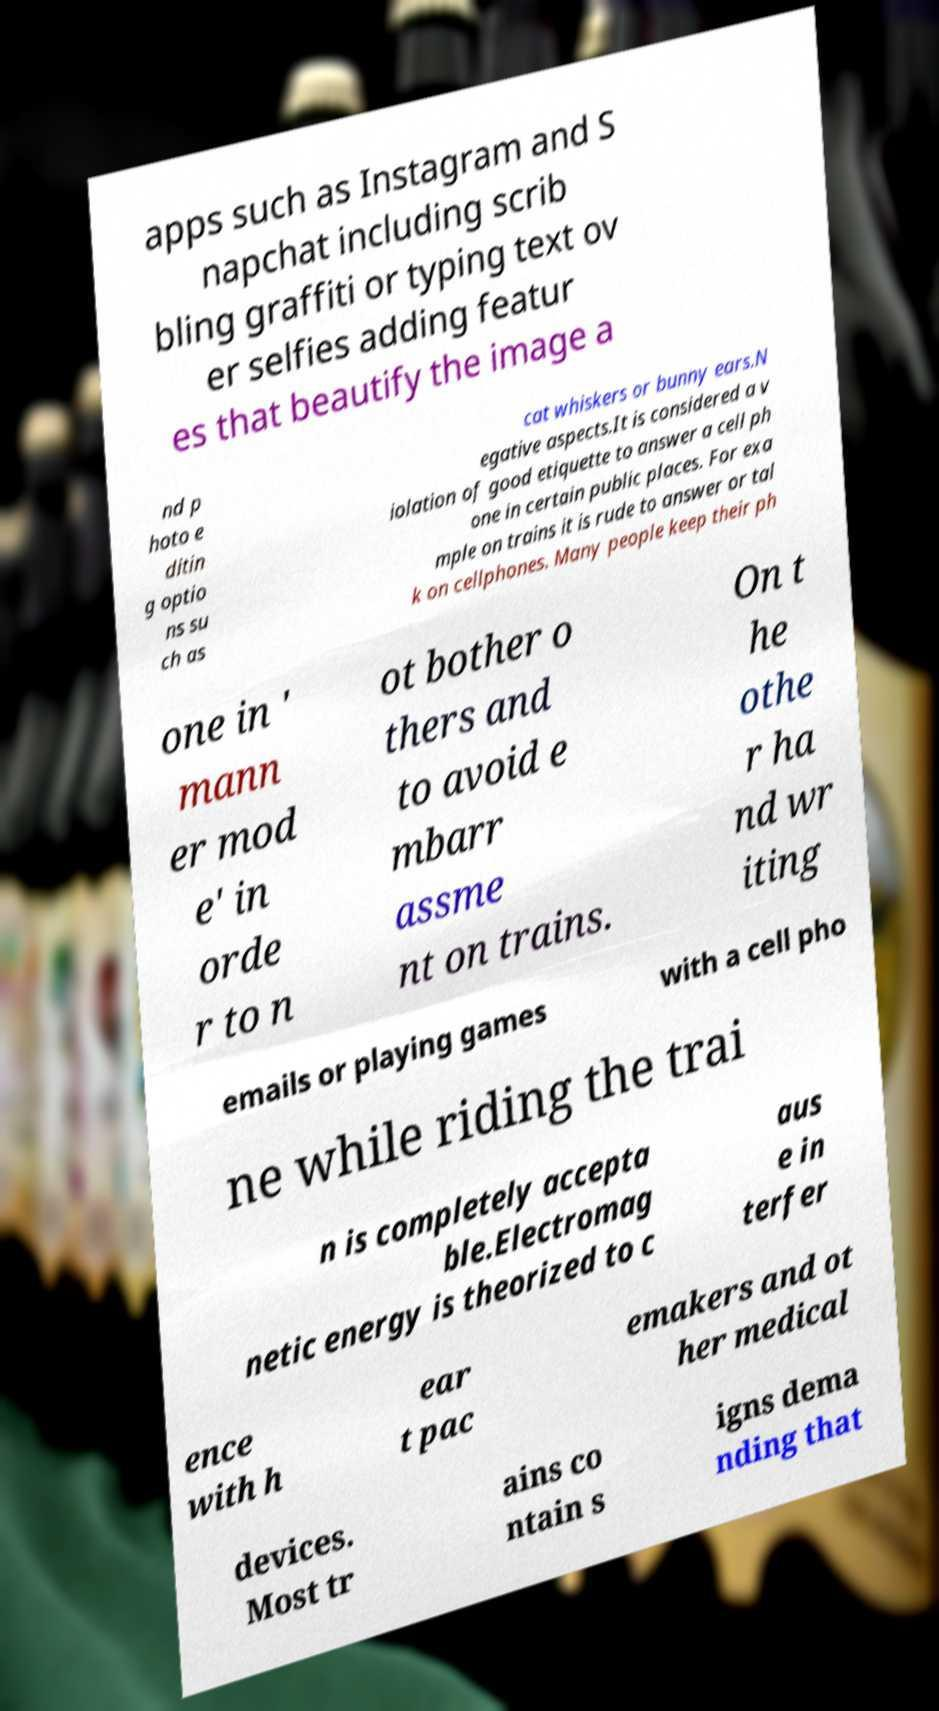Please identify and transcribe the text found in this image. apps such as Instagram and S napchat including scrib bling graffiti or typing text ov er selfies adding featur es that beautify the image a nd p hoto e ditin g optio ns su ch as cat whiskers or bunny ears.N egative aspects.It is considered a v iolation of good etiquette to answer a cell ph one in certain public places. For exa mple on trains it is rude to answer or tal k on cellphones. Many people keep their ph one in ' mann er mod e' in orde r to n ot bother o thers and to avoid e mbarr assme nt on trains. On t he othe r ha nd wr iting emails or playing games with a cell pho ne while riding the trai n is completely accepta ble.Electromag netic energy is theorized to c aus e in terfer ence with h ear t pac emakers and ot her medical devices. Most tr ains co ntain s igns dema nding that 